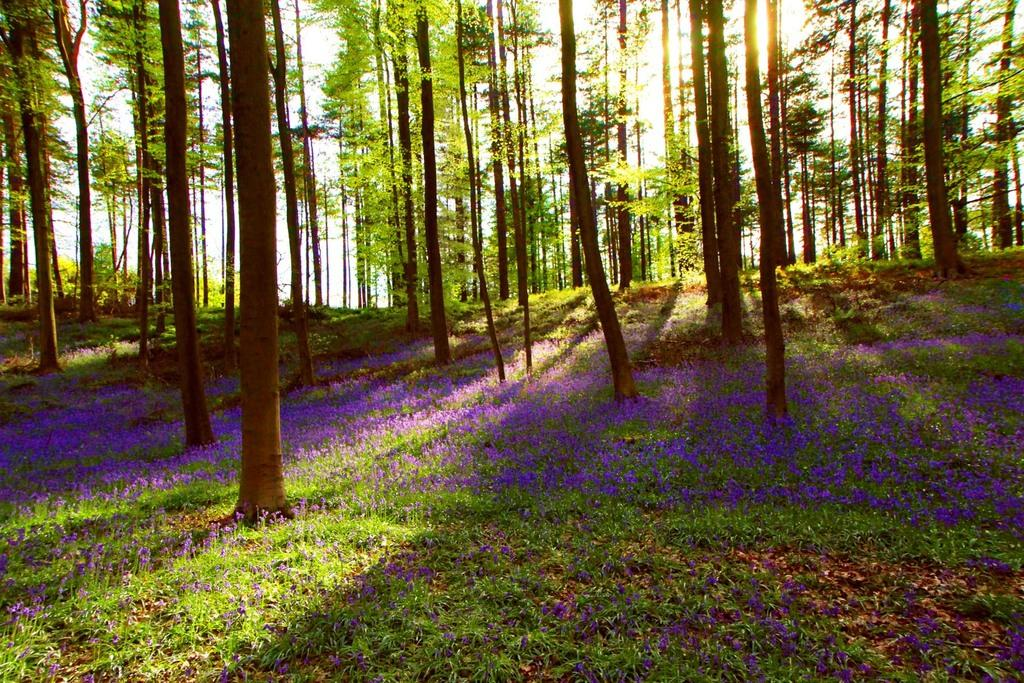What type of vegetation can be seen in the image? There are trees with branches and leaves in the image. Are there any smaller plants visible in the image? Yes, there are tiny plants with flowers in the image. What color are the flowers on the tiny plants? The flowers are violet in color. Can you tell me how the mist is affecting the angle of the paper in the image? There is no mist or paper present in the image; it features trees and tiny plants with violet flowers. 